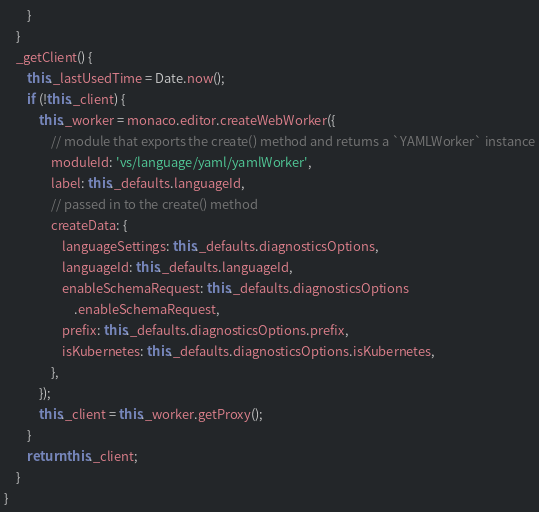<code> <loc_0><loc_0><loc_500><loc_500><_JavaScript_>        }
    }
    _getClient() {
        this._lastUsedTime = Date.now();
        if (!this._client) {
            this._worker = monaco.editor.createWebWorker({
                // module that exports the create() method and returns a `YAMLWorker` instance
                moduleId: 'vs/language/yaml/yamlWorker',
                label: this._defaults.languageId,
                // passed in to the create() method
                createData: {
                    languageSettings: this._defaults.diagnosticsOptions,
                    languageId: this._defaults.languageId,
                    enableSchemaRequest: this._defaults.diagnosticsOptions
                        .enableSchemaRequest,
                    prefix: this._defaults.diagnosticsOptions.prefix,
                    isKubernetes: this._defaults.diagnosticsOptions.isKubernetes,
                },
            });
            this._client = this._worker.getProxy();
        }
        return this._client;
    }
}
</code> 